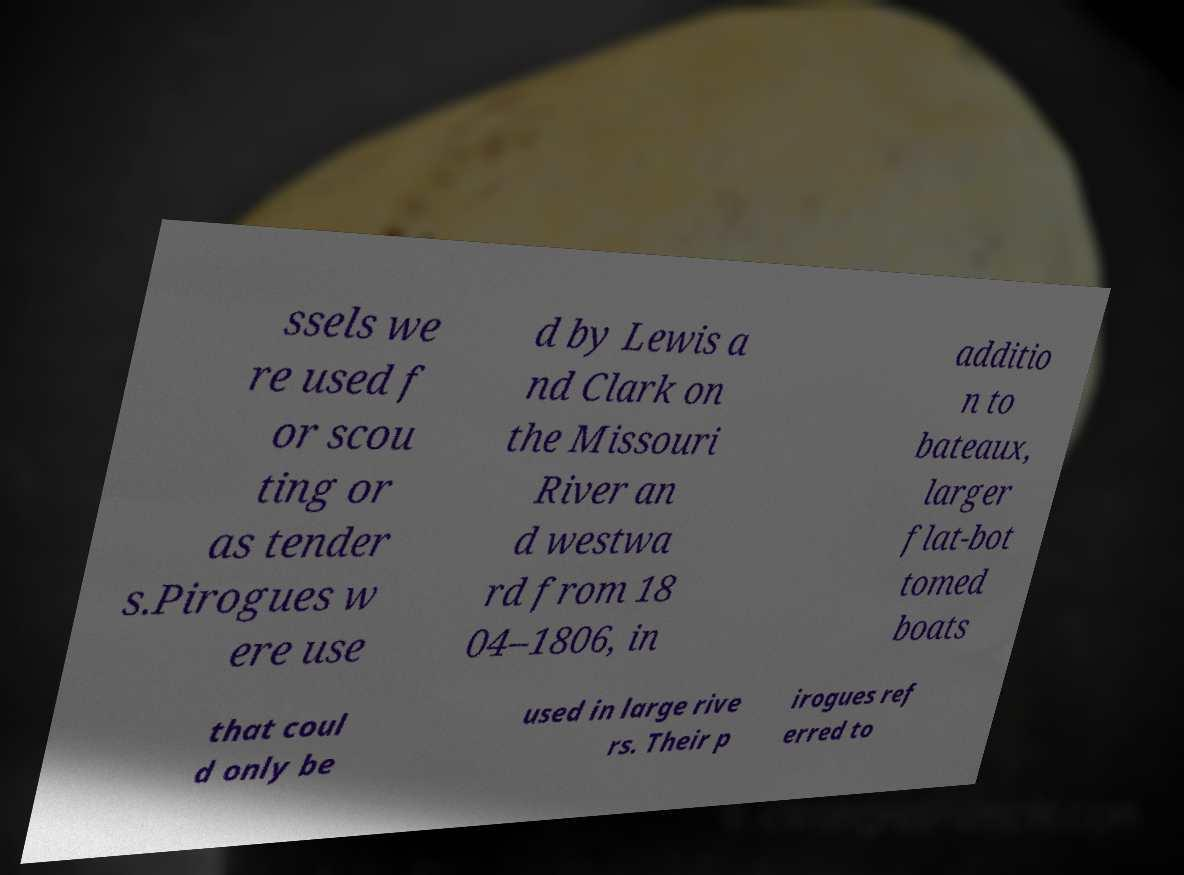What messages or text are displayed in this image? I need them in a readable, typed format. ssels we re used f or scou ting or as tender s.Pirogues w ere use d by Lewis a nd Clark on the Missouri River an d westwa rd from 18 04–1806, in additio n to bateaux, larger flat-bot tomed boats that coul d only be used in large rive rs. Their p irogues ref erred to 